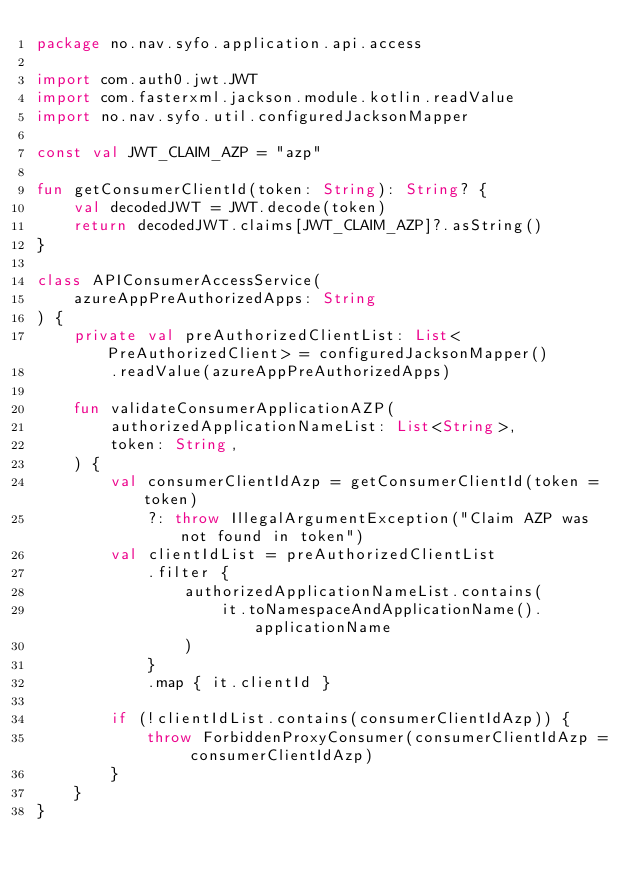<code> <loc_0><loc_0><loc_500><loc_500><_Kotlin_>package no.nav.syfo.application.api.access

import com.auth0.jwt.JWT
import com.fasterxml.jackson.module.kotlin.readValue
import no.nav.syfo.util.configuredJacksonMapper

const val JWT_CLAIM_AZP = "azp"

fun getConsumerClientId(token: String): String? {
    val decodedJWT = JWT.decode(token)
    return decodedJWT.claims[JWT_CLAIM_AZP]?.asString()
}

class APIConsumerAccessService(
    azureAppPreAuthorizedApps: String
) {
    private val preAuthorizedClientList: List<PreAuthorizedClient> = configuredJacksonMapper()
        .readValue(azureAppPreAuthorizedApps)

    fun validateConsumerApplicationAZP(
        authorizedApplicationNameList: List<String>,
        token: String,
    ) {
        val consumerClientIdAzp = getConsumerClientId(token = token)
            ?: throw IllegalArgumentException("Claim AZP was not found in token")
        val clientIdList = preAuthorizedClientList
            .filter {
                authorizedApplicationNameList.contains(
                    it.toNamespaceAndApplicationName().applicationName
                )
            }
            .map { it.clientId }

        if (!clientIdList.contains(consumerClientIdAzp)) {
            throw ForbiddenProxyConsumer(consumerClientIdAzp = consumerClientIdAzp)
        }
    }
}
</code> 